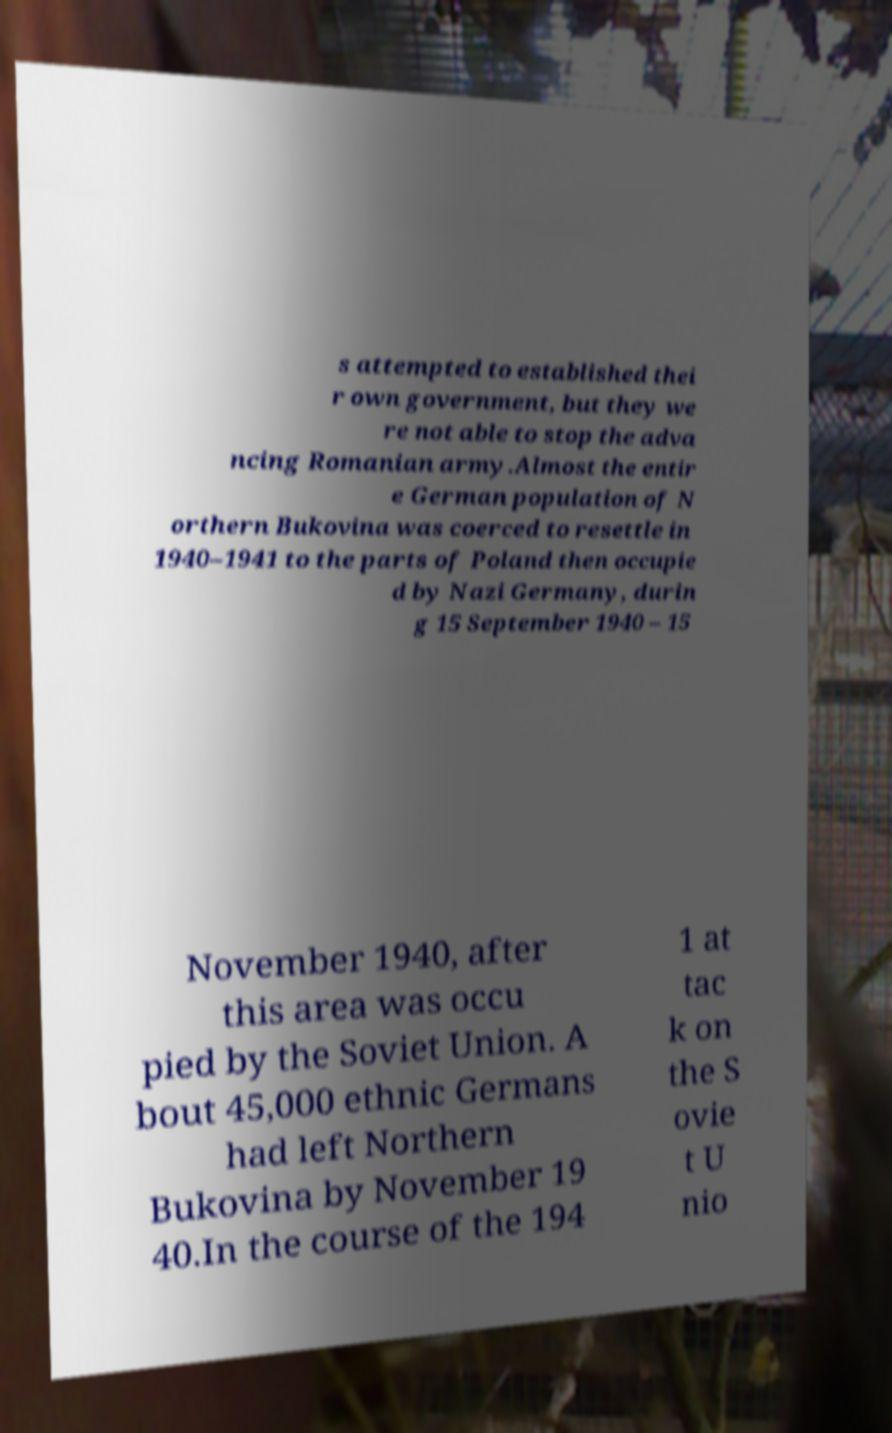I need the written content from this picture converted into text. Can you do that? s attempted to established thei r own government, but they we re not able to stop the adva ncing Romanian army.Almost the entir e German population of N orthern Bukovina was coerced to resettle in 1940–1941 to the parts of Poland then occupie d by Nazi Germany, durin g 15 September 1940 – 15 November 1940, after this area was occu pied by the Soviet Union. A bout 45,000 ethnic Germans had left Northern Bukovina by November 19 40.In the course of the 194 1 at tac k on the S ovie t U nio 